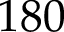Convert formula to latex. <formula><loc_0><loc_0><loc_500><loc_500>1 8 0</formula> 